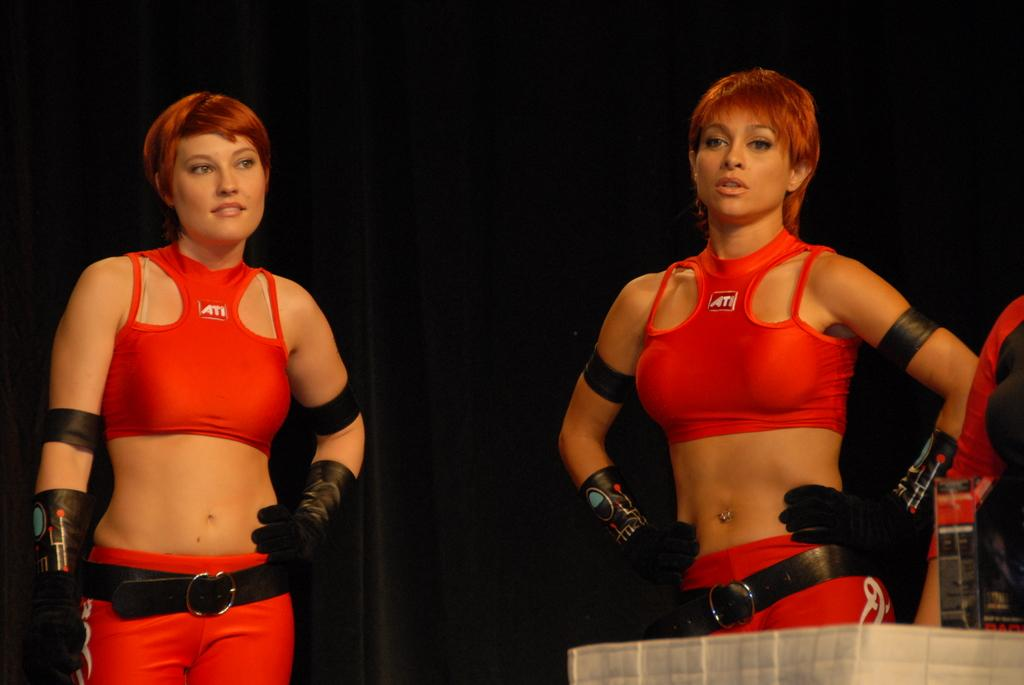Provide a one-sentence caption for the provided image. Two women in red uniforms of spandex for ATL stand waiting. 